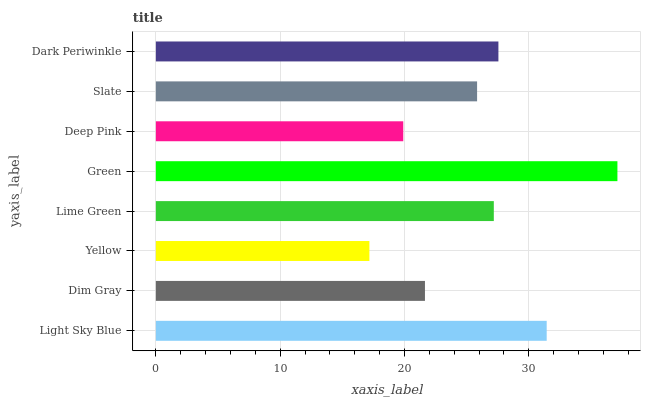Is Yellow the minimum?
Answer yes or no. Yes. Is Green the maximum?
Answer yes or no. Yes. Is Dim Gray the minimum?
Answer yes or no. No. Is Dim Gray the maximum?
Answer yes or no. No. Is Light Sky Blue greater than Dim Gray?
Answer yes or no. Yes. Is Dim Gray less than Light Sky Blue?
Answer yes or no. Yes. Is Dim Gray greater than Light Sky Blue?
Answer yes or no. No. Is Light Sky Blue less than Dim Gray?
Answer yes or no. No. Is Lime Green the high median?
Answer yes or no. Yes. Is Slate the low median?
Answer yes or no. Yes. Is Dark Periwinkle the high median?
Answer yes or no. No. Is Dark Periwinkle the low median?
Answer yes or no. No. 